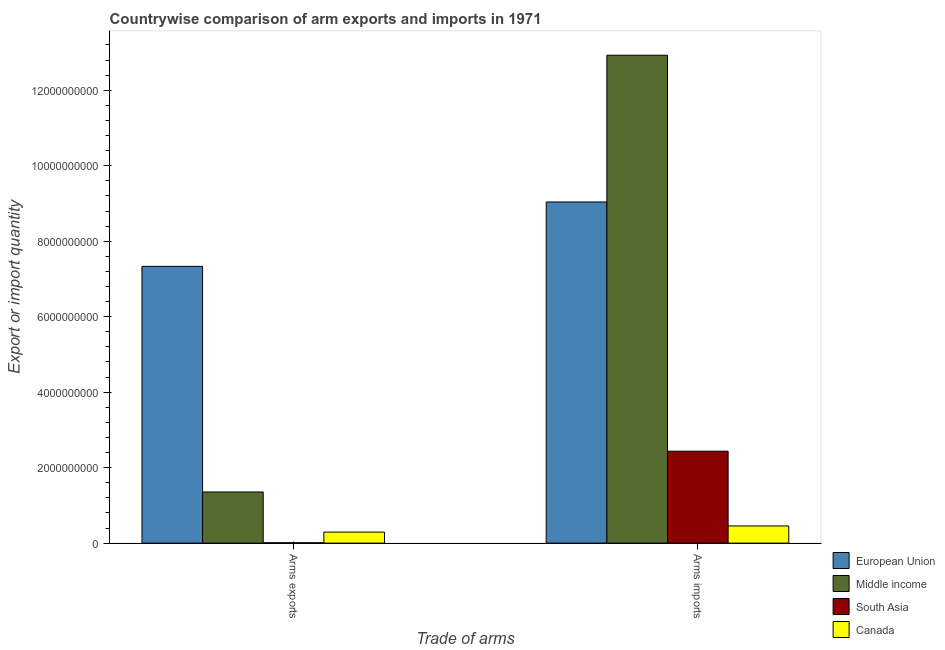How many groups of bars are there?
Offer a terse response. 2. Are the number of bars per tick equal to the number of legend labels?
Your response must be concise. Yes. Are the number of bars on each tick of the X-axis equal?
Give a very brief answer. Yes. How many bars are there on the 1st tick from the right?
Your answer should be very brief. 4. What is the label of the 2nd group of bars from the left?
Your answer should be compact. Arms imports. What is the arms exports in Middle income?
Provide a short and direct response. 1.36e+09. Across all countries, what is the maximum arms exports?
Your answer should be very brief. 7.33e+09. Across all countries, what is the minimum arms exports?
Keep it short and to the point. 9.00e+06. In which country was the arms imports maximum?
Ensure brevity in your answer.  Middle income. In which country was the arms exports minimum?
Give a very brief answer. South Asia. What is the total arms exports in the graph?
Offer a very short reply. 8.99e+09. What is the difference between the arms exports in South Asia and that in Middle income?
Make the answer very short. -1.35e+09. What is the difference between the arms imports in Middle income and the arms exports in South Asia?
Your answer should be very brief. 1.29e+1. What is the average arms exports per country?
Make the answer very short. 2.25e+09. What is the difference between the arms exports and arms imports in European Union?
Your answer should be compact. -1.71e+09. What is the ratio of the arms exports in South Asia to that in Middle income?
Your response must be concise. 0.01. In how many countries, is the arms exports greater than the average arms exports taken over all countries?
Make the answer very short. 1. What does the 1st bar from the left in Arms imports represents?
Give a very brief answer. European Union. What does the 1st bar from the right in Arms imports represents?
Your response must be concise. Canada. How many bars are there?
Ensure brevity in your answer.  8. How many countries are there in the graph?
Offer a terse response. 4. Are the values on the major ticks of Y-axis written in scientific E-notation?
Keep it short and to the point. No. Does the graph contain grids?
Offer a terse response. No. Where does the legend appear in the graph?
Your answer should be compact. Bottom right. What is the title of the graph?
Make the answer very short. Countrywise comparison of arm exports and imports in 1971. Does "Gambia, The" appear as one of the legend labels in the graph?
Make the answer very short. No. What is the label or title of the X-axis?
Offer a very short reply. Trade of arms. What is the label or title of the Y-axis?
Make the answer very short. Export or import quantity. What is the Export or import quantity of European Union in Arms exports?
Your answer should be compact. 7.33e+09. What is the Export or import quantity of Middle income in Arms exports?
Keep it short and to the point. 1.36e+09. What is the Export or import quantity in South Asia in Arms exports?
Offer a terse response. 9.00e+06. What is the Export or import quantity of Canada in Arms exports?
Make the answer very short. 2.92e+08. What is the Export or import quantity of European Union in Arms imports?
Your response must be concise. 9.04e+09. What is the Export or import quantity of Middle income in Arms imports?
Your answer should be compact. 1.29e+1. What is the Export or import quantity of South Asia in Arms imports?
Keep it short and to the point. 2.44e+09. What is the Export or import quantity of Canada in Arms imports?
Provide a short and direct response. 4.55e+08. Across all Trade of arms, what is the maximum Export or import quantity in European Union?
Your response must be concise. 9.04e+09. Across all Trade of arms, what is the maximum Export or import quantity in Middle income?
Keep it short and to the point. 1.29e+1. Across all Trade of arms, what is the maximum Export or import quantity of South Asia?
Your answer should be compact. 2.44e+09. Across all Trade of arms, what is the maximum Export or import quantity in Canada?
Your answer should be compact. 4.55e+08. Across all Trade of arms, what is the minimum Export or import quantity of European Union?
Your answer should be very brief. 7.33e+09. Across all Trade of arms, what is the minimum Export or import quantity of Middle income?
Provide a short and direct response. 1.36e+09. Across all Trade of arms, what is the minimum Export or import quantity in South Asia?
Make the answer very short. 9.00e+06. Across all Trade of arms, what is the minimum Export or import quantity of Canada?
Provide a short and direct response. 2.92e+08. What is the total Export or import quantity of European Union in the graph?
Give a very brief answer. 1.64e+1. What is the total Export or import quantity in Middle income in the graph?
Your answer should be compact. 1.43e+1. What is the total Export or import quantity of South Asia in the graph?
Ensure brevity in your answer.  2.44e+09. What is the total Export or import quantity in Canada in the graph?
Your answer should be compact. 7.47e+08. What is the difference between the Export or import quantity of European Union in Arms exports and that in Arms imports?
Provide a short and direct response. -1.71e+09. What is the difference between the Export or import quantity in Middle income in Arms exports and that in Arms imports?
Make the answer very short. -1.16e+1. What is the difference between the Export or import quantity in South Asia in Arms exports and that in Arms imports?
Provide a short and direct response. -2.43e+09. What is the difference between the Export or import quantity of Canada in Arms exports and that in Arms imports?
Keep it short and to the point. -1.63e+08. What is the difference between the Export or import quantity of European Union in Arms exports and the Export or import quantity of Middle income in Arms imports?
Provide a succinct answer. -5.60e+09. What is the difference between the Export or import quantity of European Union in Arms exports and the Export or import quantity of South Asia in Arms imports?
Offer a terse response. 4.90e+09. What is the difference between the Export or import quantity in European Union in Arms exports and the Export or import quantity in Canada in Arms imports?
Ensure brevity in your answer.  6.88e+09. What is the difference between the Export or import quantity in Middle income in Arms exports and the Export or import quantity in South Asia in Arms imports?
Provide a succinct answer. -1.08e+09. What is the difference between the Export or import quantity in Middle income in Arms exports and the Export or import quantity in Canada in Arms imports?
Give a very brief answer. 9.00e+08. What is the difference between the Export or import quantity in South Asia in Arms exports and the Export or import quantity in Canada in Arms imports?
Ensure brevity in your answer.  -4.46e+08. What is the average Export or import quantity of European Union per Trade of arms?
Ensure brevity in your answer.  8.19e+09. What is the average Export or import quantity of Middle income per Trade of arms?
Your answer should be very brief. 7.14e+09. What is the average Export or import quantity in South Asia per Trade of arms?
Offer a very short reply. 1.22e+09. What is the average Export or import quantity of Canada per Trade of arms?
Offer a terse response. 3.74e+08. What is the difference between the Export or import quantity of European Union and Export or import quantity of Middle income in Arms exports?
Provide a succinct answer. 5.98e+09. What is the difference between the Export or import quantity of European Union and Export or import quantity of South Asia in Arms exports?
Provide a short and direct response. 7.32e+09. What is the difference between the Export or import quantity in European Union and Export or import quantity in Canada in Arms exports?
Your answer should be very brief. 7.04e+09. What is the difference between the Export or import quantity of Middle income and Export or import quantity of South Asia in Arms exports?
Ensure brevity in your answer.  1.35e+09. What is the difference between the Export or import quantity of Middle income and Export or import quantity of Canada in Arms exports?
Your response must be concise. 1.06e+09. What is the difference between the Export or import quantity in South Asia and Export or import quantity in Canada in Arms exports?
Ensure brevity in your answer.  -2.83e+08. What is the difference between the Export or import quantity of European Union and Export or import quantity of Middle income in Arms imports?
Make the answer very short. -3.89e+09. What is the difference between the Export or import quantity in European Union and Export or import quantity in South Asia in Arms imports?
Offer a terse response. 6.60e+09. What is the difference between the Export or import quantity in European Union and Export or import quantity in Canada in Arms imports?
Your answer should be very brief. 8.58e+09. What is the difference between the Export or import quantity in Middle income and Export or import quantity in South Asia in Arms imports?
Your answer should be compact. 1.05e+1. What is the difference between the Export or import quantity of Middle income and Export or import quantity of Canada in Arms imports?
Make the answer very short. 1.25e+1. What is the difference between the Export or import quantity of South Asia and Export or import quantity of Canada in Arms imports?
Provide a short and direct response. 1.98e+09. What is the ratio of the Export or import quantity of European Union in Arms exports to that in Arms imports?
Your answer should be compact. 0.81. What is the ratio of the Export or import quantity in Middle income in Arms exports to that in Arms imports?
Provide a short and direct response. 0.1. What is the ratio of the Export or import quantity in South Asia in Arms exports to that in Arms imports?
Provide a succinct answer. 0. What is the ratio of the Export or import quantity in Canada in Arms exports to that in Arms imports?
Ensure brevity in your answer.  0.64. What is the difference between the highest and the second highest Export or import quantity in European Union?
Give a very brief answer. 1.71e+09. What is the difference between the highest and the second highest Export or import quantity in Middle income?
Ensure brevity in your answer.  1.16e+1. What is the difference between the highest and the second highest Export or import quantity in South Asia?
Offer a terse response. 2.43e+09. What is the difference between the highest and the second highest Export or import quantity in Canada?
Offer a very short reply. 1.63e+08. What is the difference between the highest and the lowest Export or import quantity of European Union?
Make the answer very short. 1.71e+09. What is the difference between the highest and the lowest Export or import quantity of Middle income?
Your answer should be very brief. 1.16e+1. What is the difference between the highest and the lowest Export or import quantity of South Asia?
Offer a very short reply. 2.43e+09. What is the difference between the highest and the lowest Export or import quantity in Canada?
Ensure brevity in your answer.  1.63e+08. 